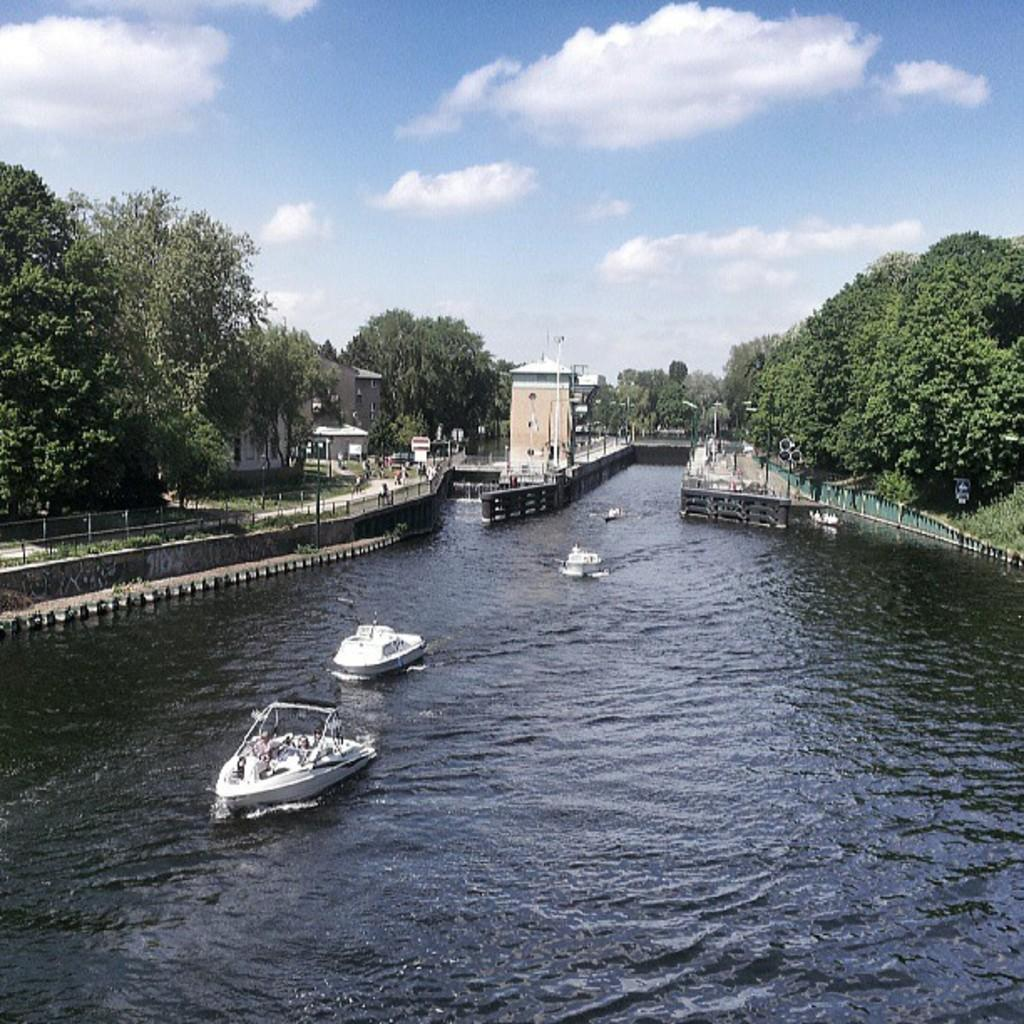What is on the water in the image? There are boats on the water in the image. What structures can be seen in the image? There are buildings visible in the image. What type of vegetation is present in the image? There are trees in the image. What part of the natural environment is visible in the image? The sky is visible in the background of the image. What disease is affecting the trees in the image? There is no indication of any disease affecting the trees in the image; they appear healthy. What boundary is visible in the image? There is no boundary visible in the image; it features boats, buildings, trees, and the sky. 